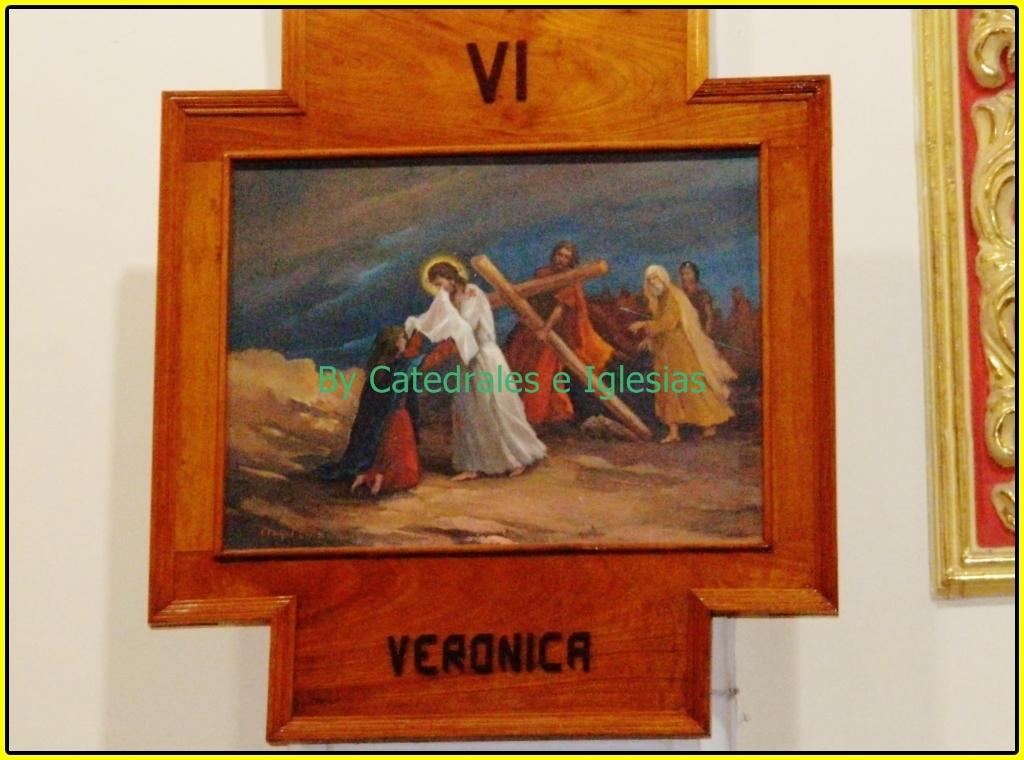Provide a one-sentence caption for the provided image. A religious painting that has the name Veronica and a roman numeral for six on it. 